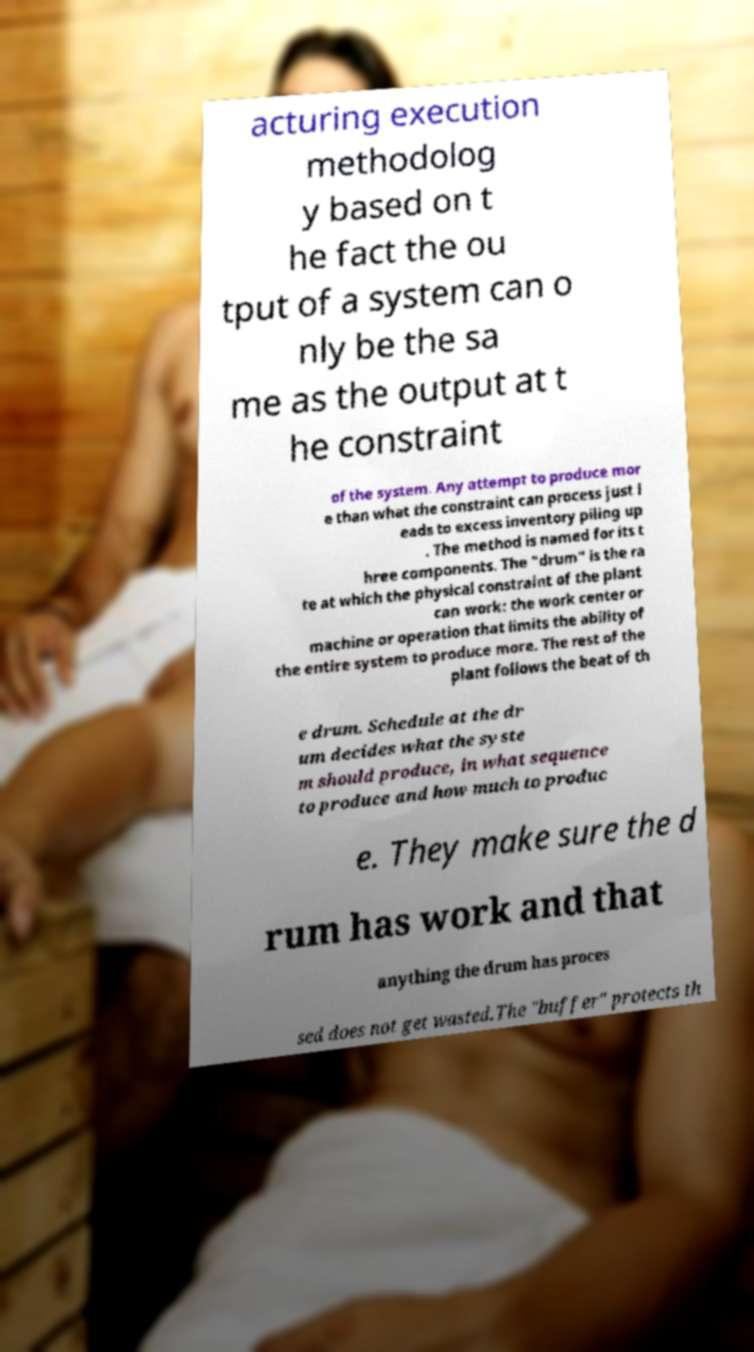I need the written content from this picture converted into text. Can you do that? acturing execution methodolog y based on t he fact the ou tput of a system can o nly be the sa me as the output at t he constraint of the system. Any attempt to produce mor e than what the constraint can process just l eads to excess inventory piling up . The method is named for its t hree components. The "drum" is the ra te at which the physical constraint of the plant can work: the work center or machine or operation that limits the ability of the entire system to produce more. The rest of the plant follows the beat of th e drum. Schedule at the dr um decides what the syste m should produce, in what sequence to produce and how much to produc e. They make sure the d rum has work and that anything the drum has proces sed does not get wasted.The "buffer" protects th 